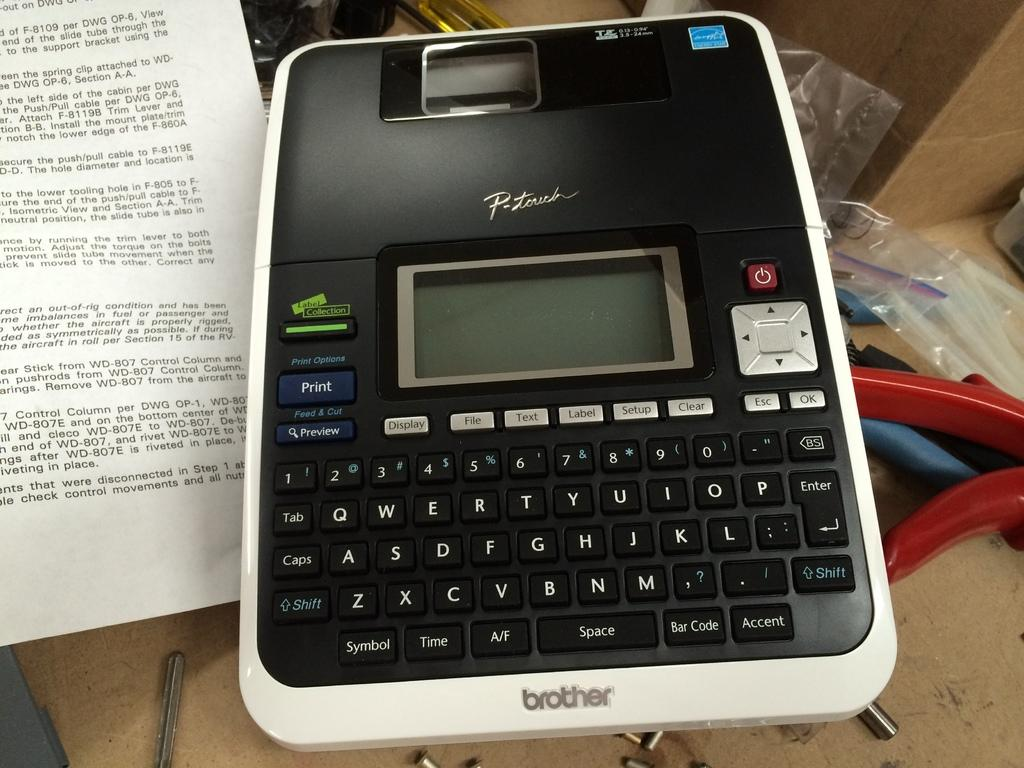<image>
Describe the image concisely. A Brother brand label maker appears to be on a work station. 